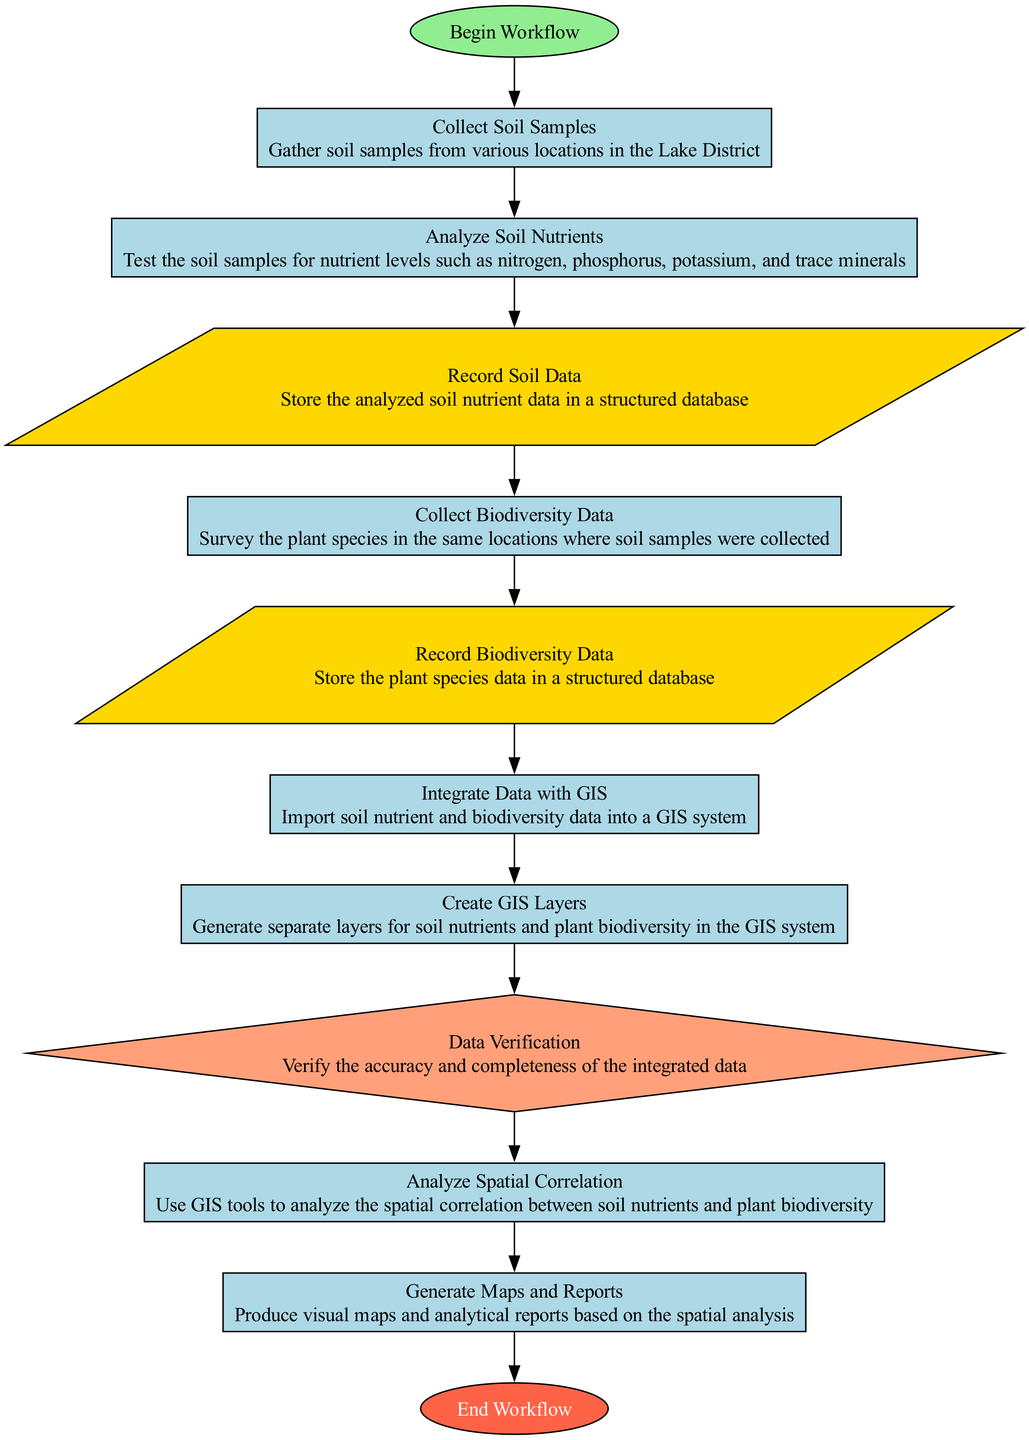What is the first step in the workflow? The workflow begins with the "Begin Workflow" node, which is identified as the starting point of the process.
Answer: Begin Workflow How many processes are in the workflow? By counting the nodes labeled as "Process," we find that there are eight processes in total throughout the workflow.
Answer: 8 What type of node is "Record Soil Data"? The "Record Soil Data" node is classified as a "Data" type node, which is characterized by its parallelogram shape in the diagram.
Answer: Data Which node follows "Collect Biodiversity Data"? The node that follows "Collect Biodiversity Data" is "Record Biodiversity Data," indicating the action taken after collecting the biodiversity information.
Answer: Record Biodiversity Data What is the last step in the workflow? The final step takes place at the "End Workflow" node, indicating the conclusion of the entire process.
Answer: End Workflow After "Integrate Data with GIS," what is the next process? The process that follows "Integrate Data with GIS" is "Create GIS Layers," which involves generating separate layers for the collected data.
Answer: Create GIS Layers Which node appears before the "Data Verification" decision point? The node that appears immediately before "Data Verification" is "Create GIS Layers," representing the last process before the decision is made regarding data accuracy.
Answer: Create GIS Layers What type of node is "Analyze Spatial Correlation"? The "Analyze Spatial Correlation" node is categorized as a "Process" type, reflecting the nature of the operation performed in that step.
Answer: Process 